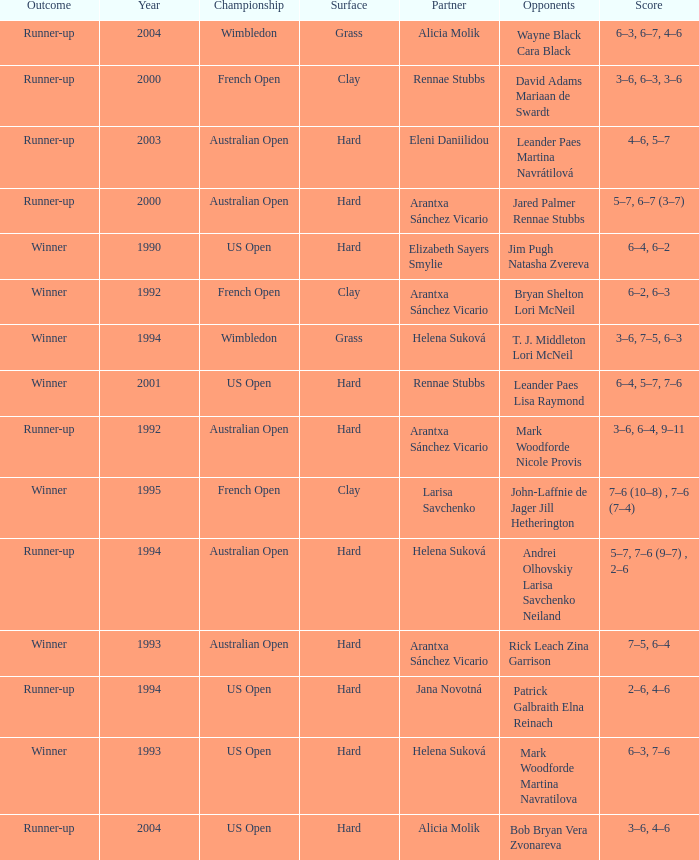Which Score has smaller than 1994, and a Partner of elizabeth sayers smylie? 6–4, 6–2. I'm looking to parse the entire table for insights. Could you assist me with that? {'header': ['Outcome', 'Year', 'Championship', 'Surface', 'Partner', 'Opponents', 'Score'], 'rows': [['Runner-up', '2004', 'Wimbledon', 'Grass', 'Alicia Molik', 'Wayne Black Cara Black', '6–3, 6–7, 4–6'], ['Runner-up', '2000', 'French Open', 'Clay', 'Rennae Stubbs', 'David Adams Mariaan de Swardt', '3–6, 6–3, 3–6'], ['Runner-up', '2003', 'Australian Open', 'Hard', 'Eleni Daniilidou', 'Leander Paes Martina Navrátilová', '4–6, 5–7'], ['Runner-up', '2000', 'Australian Open', 'Hard', 'Arantxa Sánchez Vicario', 'Jared Palmer Rennae Stubbs', '5–7, 6–7 (3–7)'], ['Winner', '1990', 'US Open', 'Hard', 'Elizabeth Sayers Smylie', 'Jim Pugh Natasha Zvereva', '6–4, 6–2'], ['Winner', '1992', 'French Open', 'Clay', 'Arantxa Sánchez Vicario', 'Bryan Shelton Lori McNeil', '6–2, 6–3'], ['Winner', '1994', 'Wimbledon', 'Grass', 'Helena Suková', 'T. J. Middleton Lori McNeil', '3–6, 7–5, 6–3'], ['Winner', '2001', 'US Open', 'Hard', 'Rennae Stubbs', 'Leander Paes Lisa Raymond', '6–4, 5–7, 7–6'], ['Runner-up', '1992', 'Australian Open', 'Hard', 'Arantxa Sánchez Vicario', 'Mark Woodforde Nicole Provis', '3–6, 6–4, 9–11'], ['Winner', '1995', 'French Open', 'Clay', 'Larisa Savchenko', 'John-Laffnie de Jager Jill Hetherington', '7–6 (10–8) , 7–6 (7–4)'], ['Runner-up', '1994', 'Australian Open', 'Hard', 'Helena Suková', 'Andrei Olhovskiy Larisa Savchenko Neiland', '5–7, 7–6 (9–7) , 2–6'], ['Winner', '1993', 'Australian Open', 'Hard', 'Arantxa Sánchez Vicario', 'Rick Leach Zina Garrison', '7–5, 6–4'], ['Runner-up', '1994', 'US Open', 'Hard', 'Jana Novotná', 'Patrick Galbraith Elna Reinach', '2–6, 4–6'], ['Winner', '1993', 'US Open', 'Hard', 'Helena Suková', 'Mark Woodforde Martina Navratilova', '6–3, 7–6'], ['Runner-up', '2004', 'US Open', 'Hard', 'Alicia Molik', 'Bob Bryan Vera Zvonareva', '3–6, 4–6']]} 